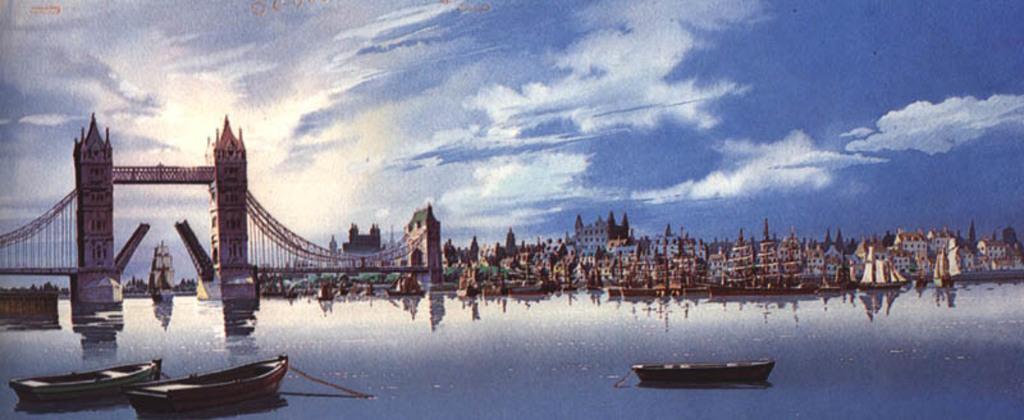Please provide a concise description of this image. In this image there is the water. There are boats on the water. To the left there is a bridge across the water. In the background there are buildings and boats on the water. At the top there is the sky. 